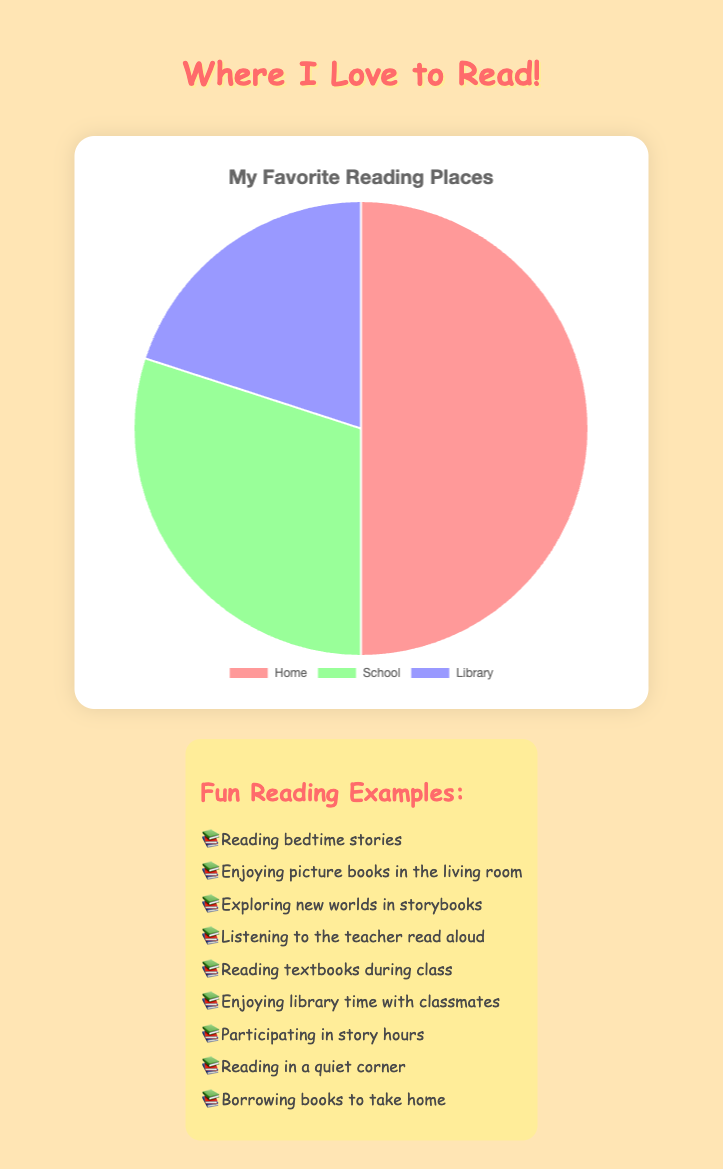Where is the most common place to read books? The pie chart shows the largest portion is for "Home," which occupies half of the chart.
Answer: Home Which place is less popular for reading: School or Library? By comparing the sizes of the sections, "Library" is smaller than "School" on the pie chart.
Answer: Library How much more popular is reading at home compared to reading at school? Reading at home has a percentage of 50%, and reading at school is 30%. The difference is 50% - 30%.
Answer: 20% What percentage of book reading happens at schools and libraries combined? Add the percentages for School (30%) and Library (20%).
Answer: 50% Which section of the pie chart is represented by the color red? By checking the color coding in the chart, "Home" is represented by the color red.
Answer: Home If you add the reading times at Home and Library, do they make up more than half of the total reading time? Home (50%) + Library (20%) = 70%, which is greater than 50%.
Answer: Yes How many places are represented in the pie chart? The pie chart has labels for Home, School, and Library. Counting these gives a total of 3 places.
Answer: 3 How does the percentage of reading at home compare to the combined percentage of reading at school and in the library? Reading at home is 50%, combined reading at school and library is 30% + 20% = 50%. They are equal.
Answer: Equal If we were to split up all the reading time evenly between the three places, how much would each place get? The total reading time would be split into three equal parts: 100% ÷ 3 ≈ 33.33%.
Answer: 33.33% What portion of the reading percentage does not happen at home? Total percentage is 100%, subtract the home percentage: 100% - 50%.
Answer: 50% 